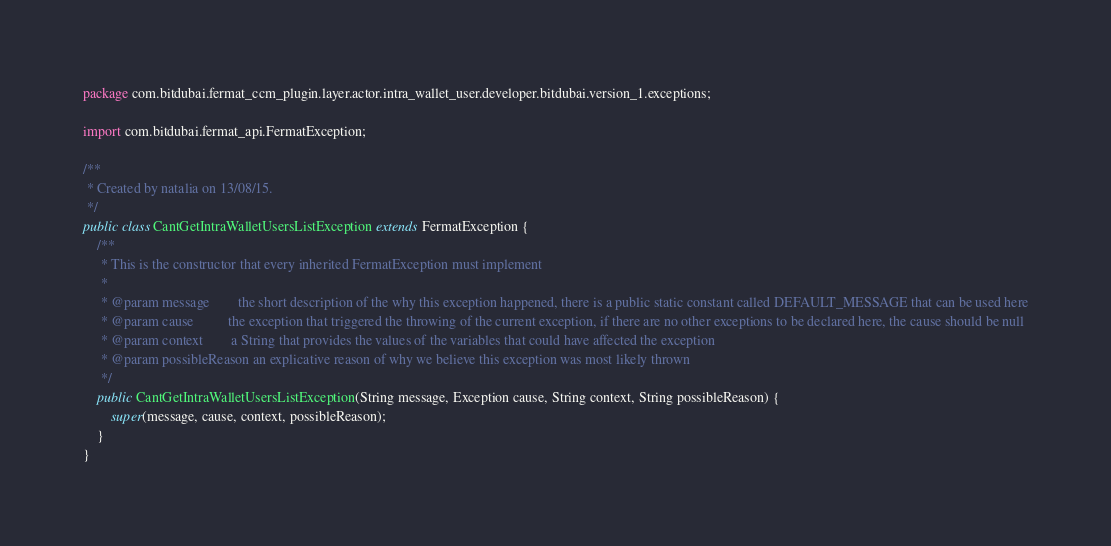Convert code to text. <code><loc_0><loc_0><loc_500><loc_500><_Java_>package com.bitdubai.fermat_ccm_plugin.layer.actor.intra_wallet_user.developer.bitdubai.version_1.exceptions;

import com.bitdubai.fermat_api.FermatException;

/**
 * Created by natalia on 13/08/15.
 */
public class CantGetIntraWalletUsersListException extends FermatException {
    /**
     * This is the constructor that every inherited FermatException must implement
     *
     * @param message        the short description of the why this exception happened, there is a public static constant called DEFAULT_MESSAGE that can be used here
     * @param cause          the exception that triggered the throwing of the current exception, if there are no other exceptions to be declared here, the cause should be null
     * @param context        a String that provides the values of the variables that could have affected the exception
     * @param possibleReason an explicative reason of why we believe this exception was most likely thrown
     */
    public CantGetIntraWalletUsersListException(String message, Exception cause, String context, String possibleReason) {
        super(message, cause, context, possibleReason);
    }
}</code> 